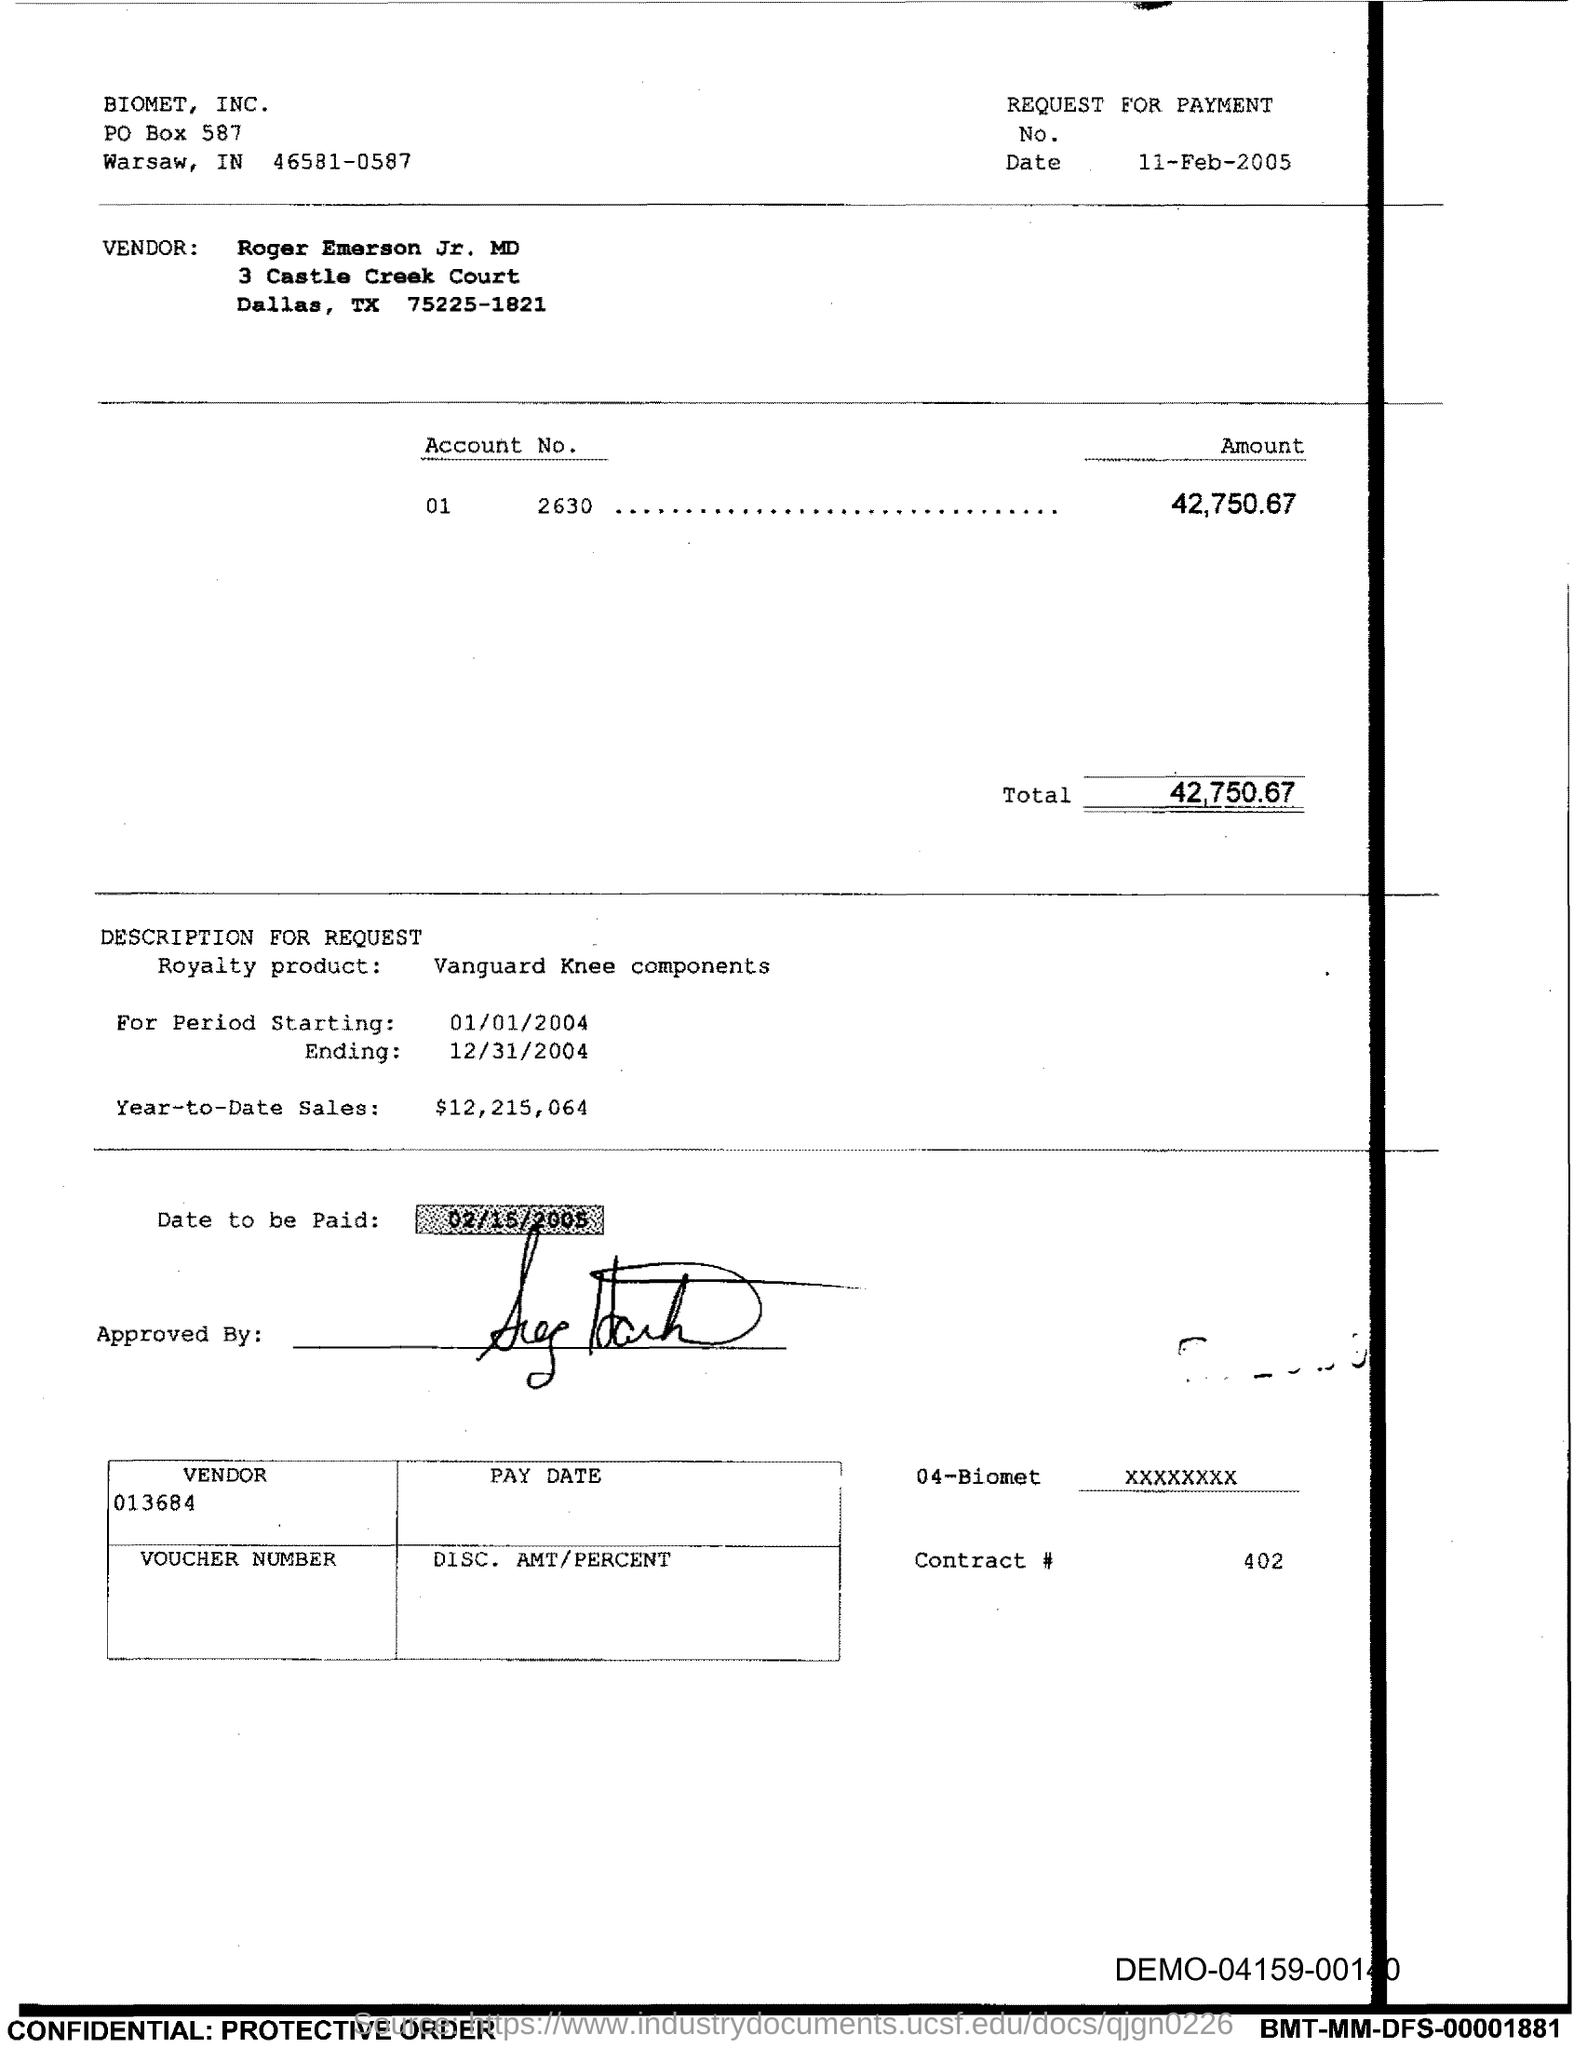What is the amount mentioned in this voucher?
Keep it short and to the point. 42,750.67. What is the payment due date mentioned in this voucher?
Provide a succinct answer. 02/15/2005. 